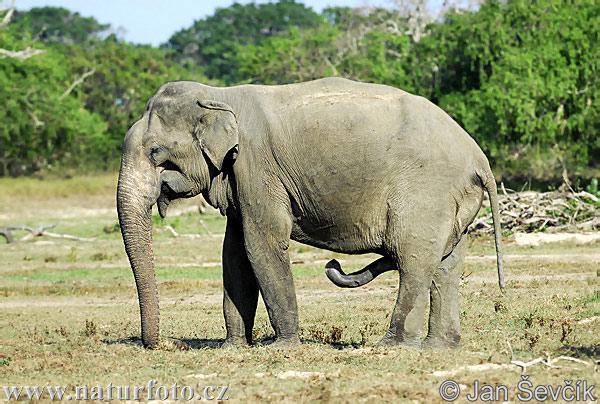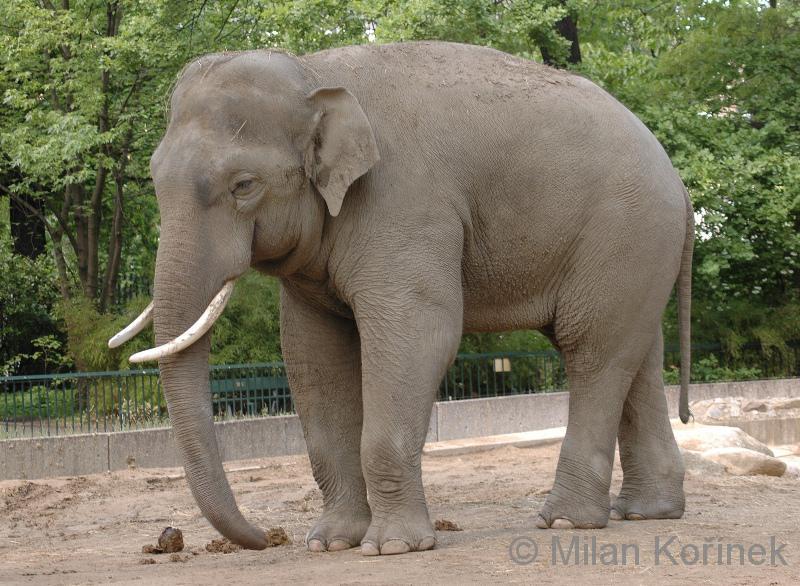The first image is the image on the left, the second image is the image on the right. Evaluate the accuracy of this statement regarding the images: "There is exactly one elephant in the image on the right.". Is it true? Answer yes or no. Yes. 